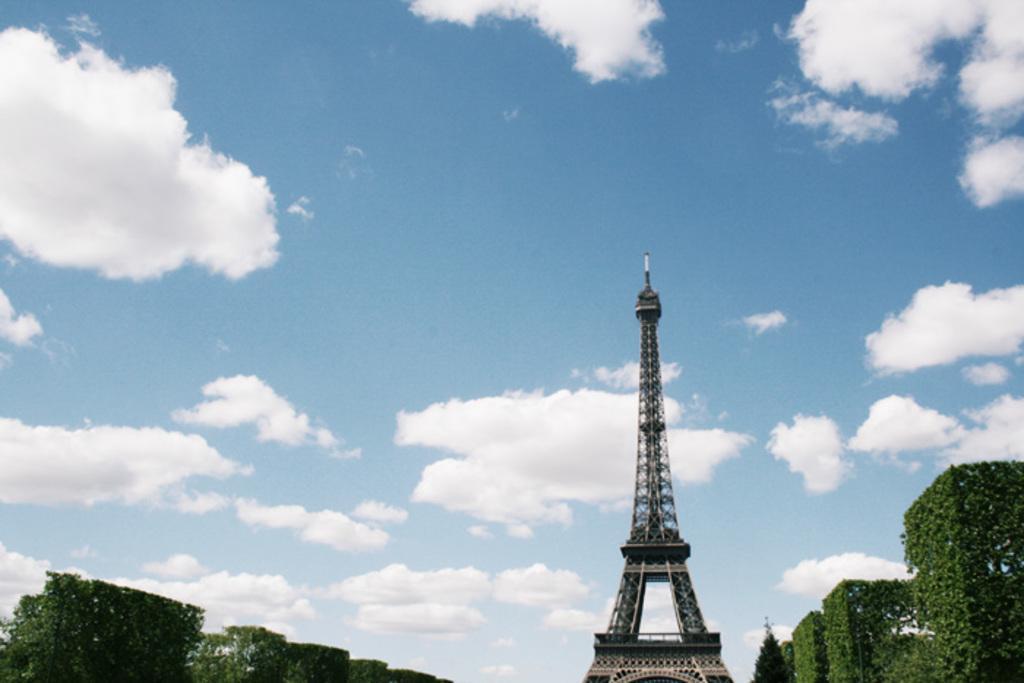Describe this image in one or two sentences. In this picture I can observe an Eiffel tower. On either sides of the picture I can observe some plants on the ground. In the background there are some clouds in the sky. 